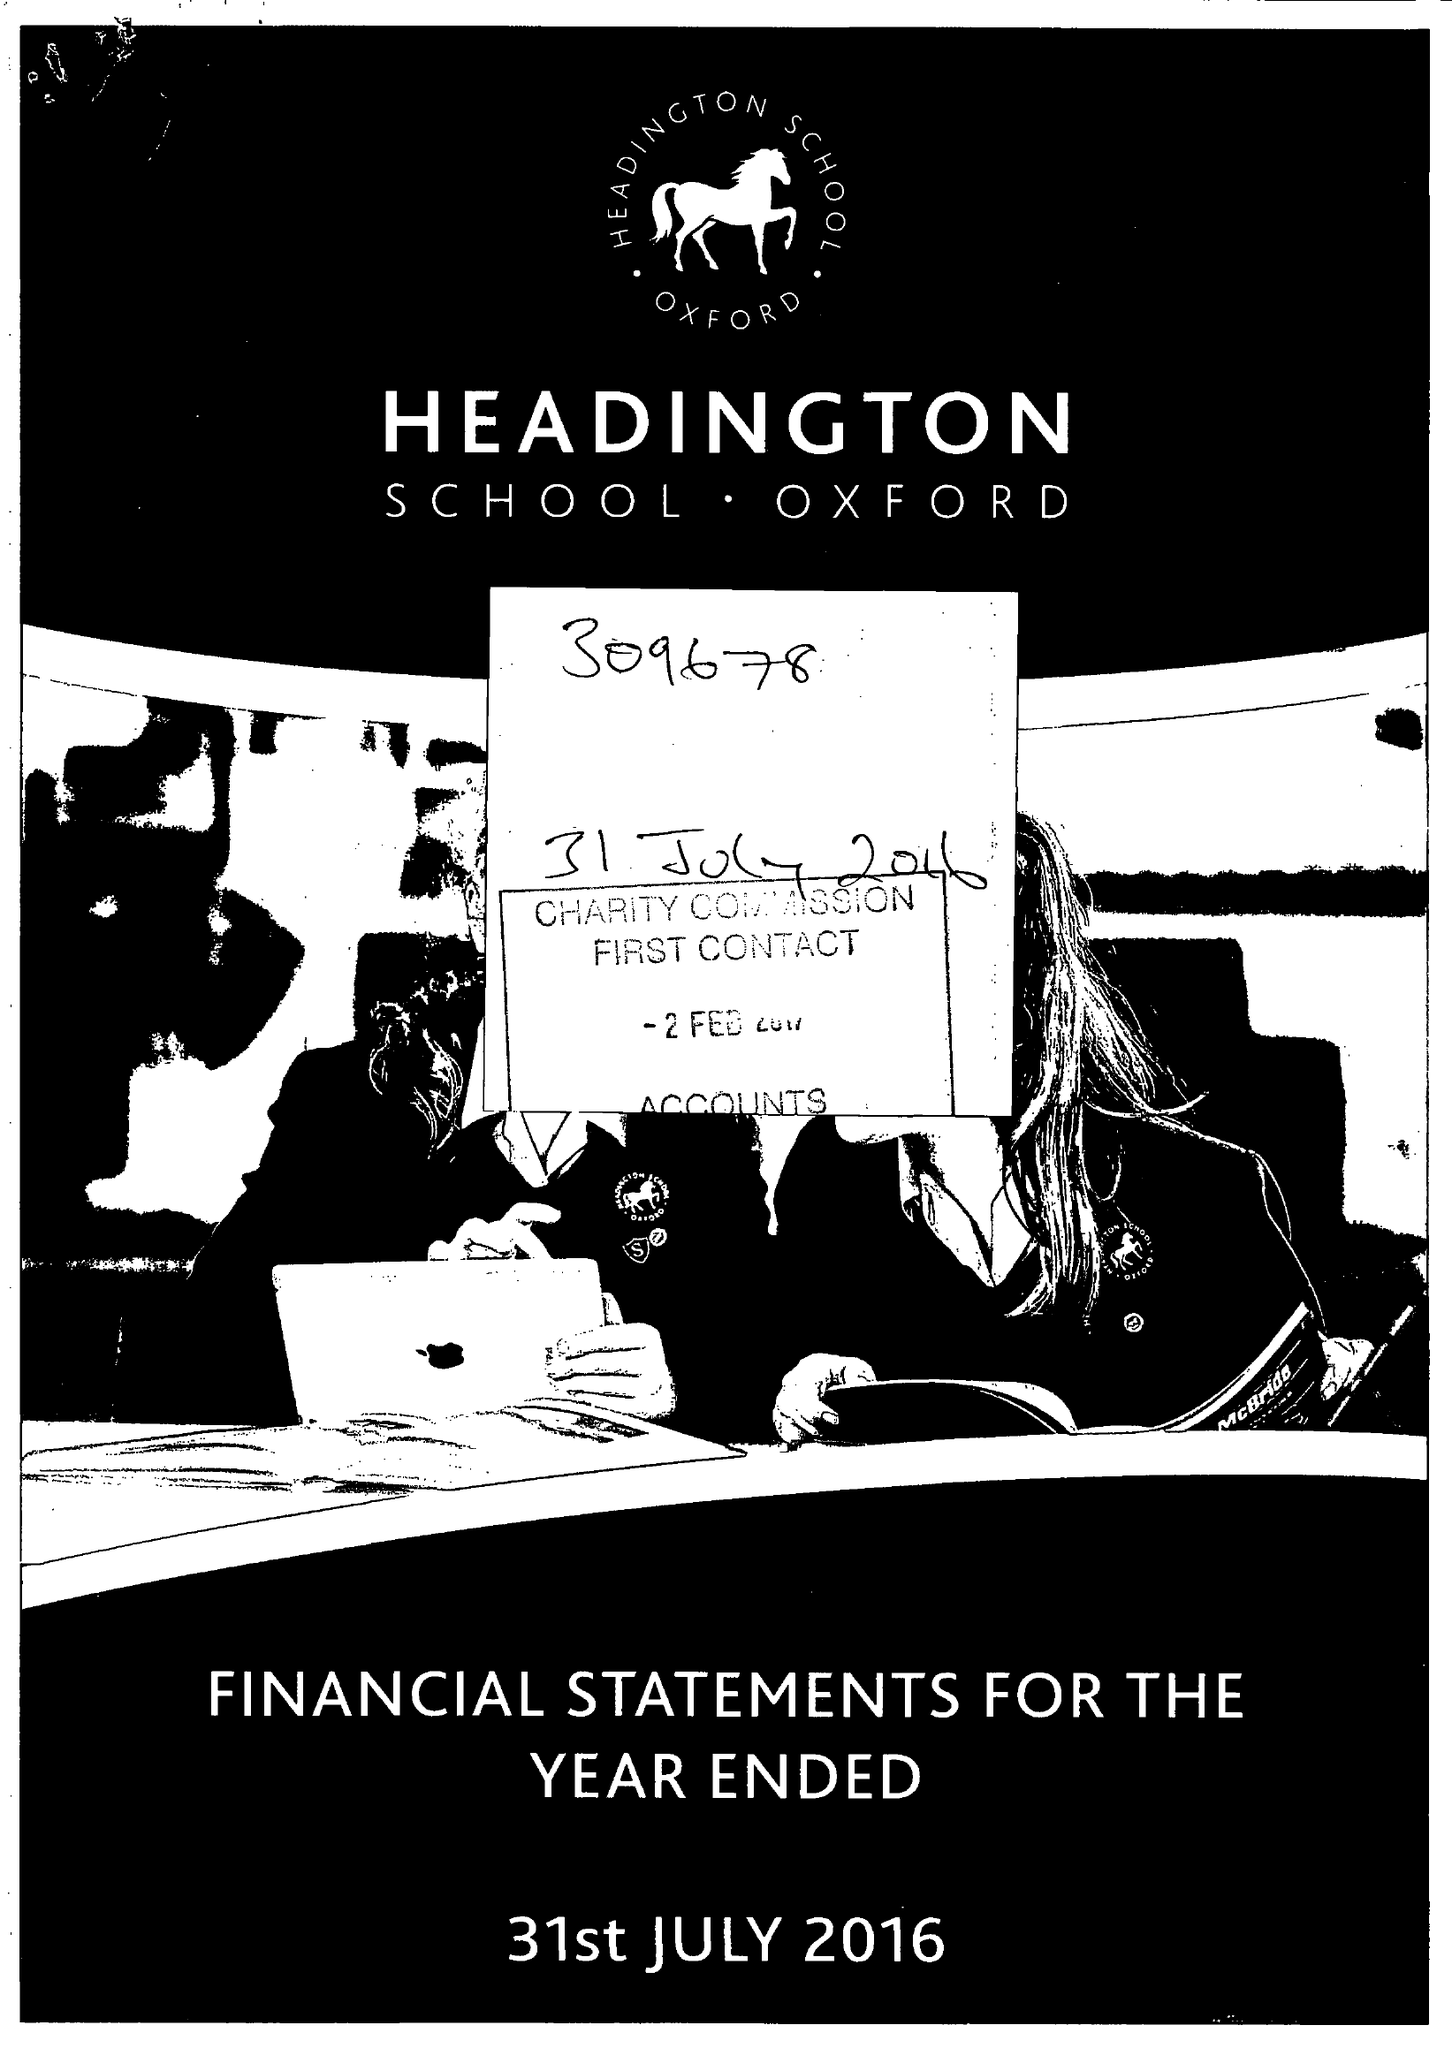What is the value for the charity_name?
Answer the question using a single word or phrase. Headington School Oxford Ltd. 